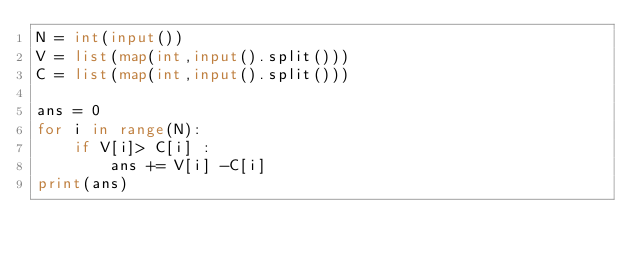<code> <loc_0><loc_0><loc_500><loc_500><_Python_>N = int(input())
V = list(map(int,input().split()))
C = list(map(int,input().split()))

ans = 0
for i in range(N):
    if V[i]> C[i] :
        ans += V[i] -C[i]
print(ans)</code> 